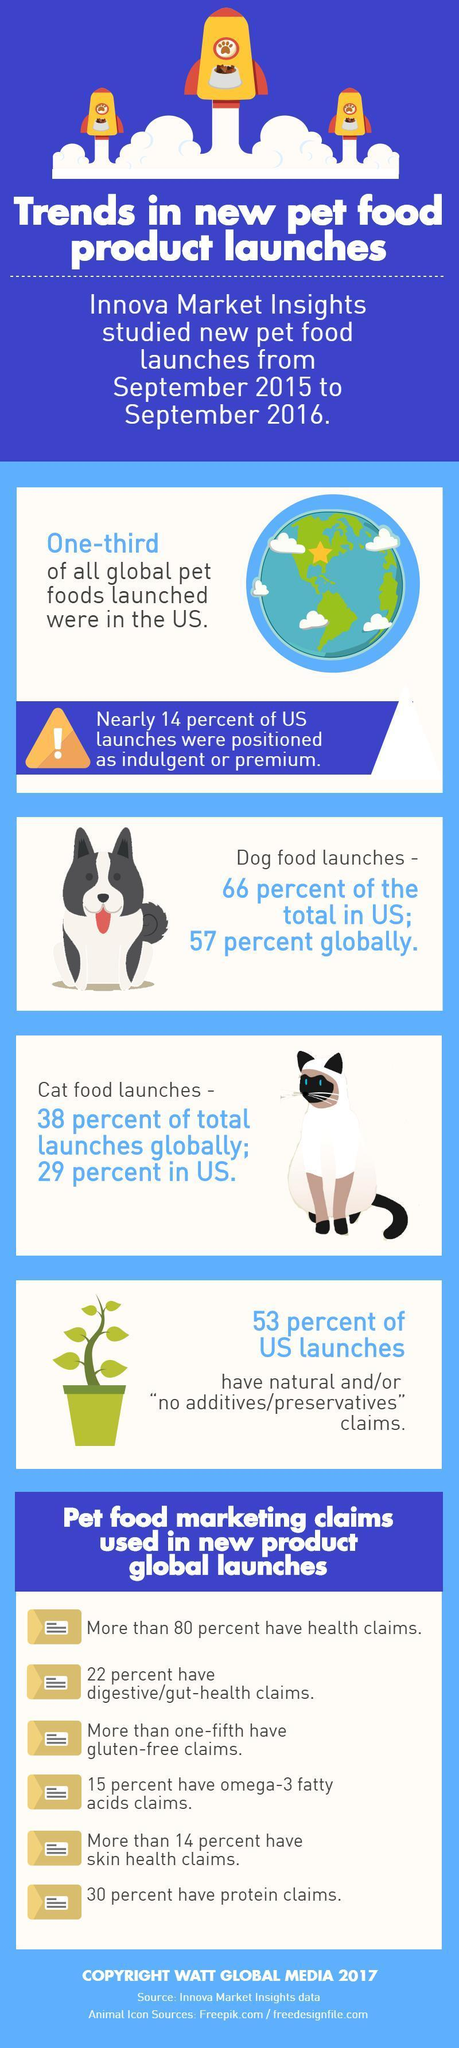What is total percentage of dog and cat food launches globally?
Answer the question with a short phrase. 95% What is total percentage of dog and cat food launches in the US? 95% 